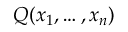Convert formula to latex. <formula><loc_0><loc_0><loc_500><loc_500>Q ( x _ { 1 } , \dots , x _ { n } )</formula> 